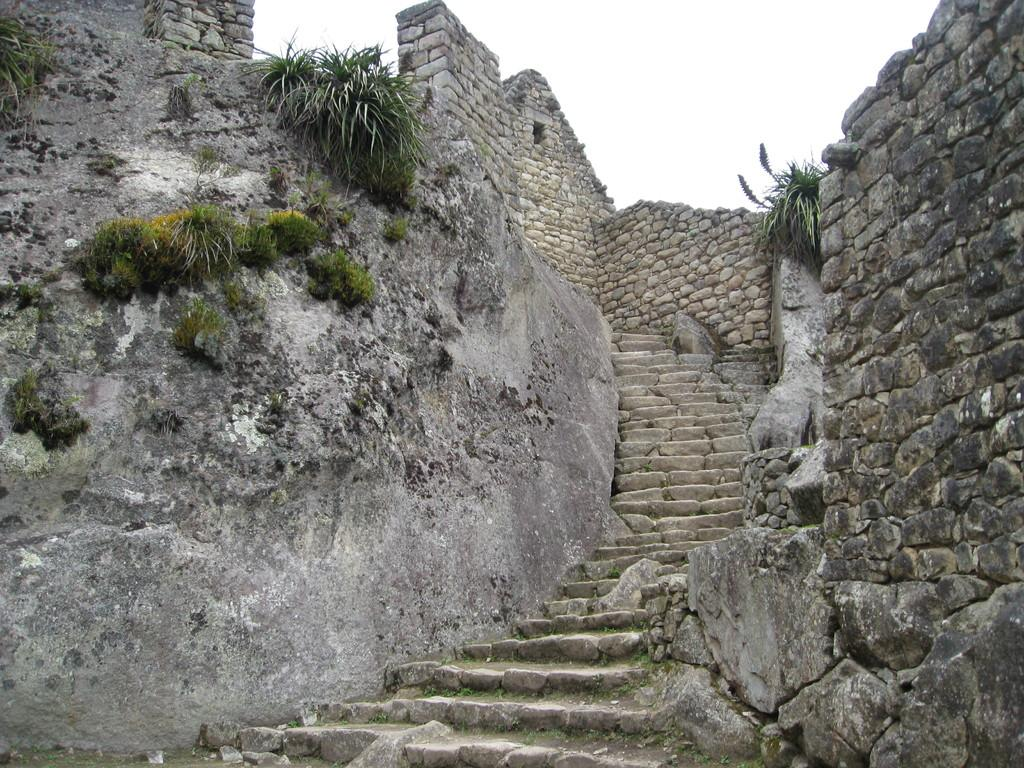What can be seen in the image that people might use to move between different levels? There are steps in the image that people might use to move between different levels. What material is used to construct the walls around the steps? The walls around the steps are made up of stones. Is there a stream of water flowing alongside the steps in the image? There is no mention of a stream of water in the provided facts, so it cannot be determined if one is present in the image. 